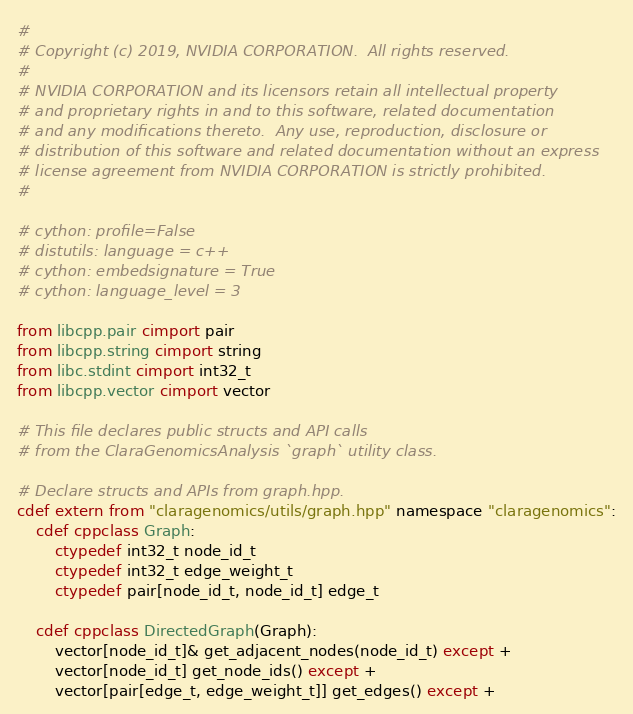Convert code to text. <code><loc_0><loc_0><loc_500><loc_500><_Cython_>#
# Copyright (c) 2019, NVIDIA CORPORATION.  All rights reserved.
#
# NVIDIA CORPORATION and its licensors retain all intellectual property
# and proprietary rights in and to this software, related documentation
# and any modifications thereto.  Any use, reproduction, disclosure or
# distribution of this software and related documentation without an express
# license agreement from NVIDIA CORPORATION is strictly prohibited.
#

# cython: profile=False
# distutils: language = c++
# cython: embedsignature = True
# cython: language_level = 3

from libcpp.pair cimport pair
from libcpp.string cimport string
from libc.stdint cimport int32_t
from libcpp.vector cimport vector

# This file declares public structs and API calls 
# from the ClaraGenomicsAnalysis `graph` utility class.

# Declare structs and APIs from graph.hpp.
cdef extern from "claragenomics/utils/graph.hpp" namespace "claragenomics":
    cdef cppclass Graph:
        ctypedef int32_t node_id_t 
        ctypedef int32_t edge_weight_t 
        ctypedef pair[node_id_t, node_id_t] edge_t

    cdef cppclass DirectedGraph(Graph):
        vector[node_id_t]& get_adjacent_nodes(node_id_t) except +
        vector[node_id_t] get_node_ids() except +
        vector[pair[edge_t, edge_weight_t]] get_edges() except +</code> 